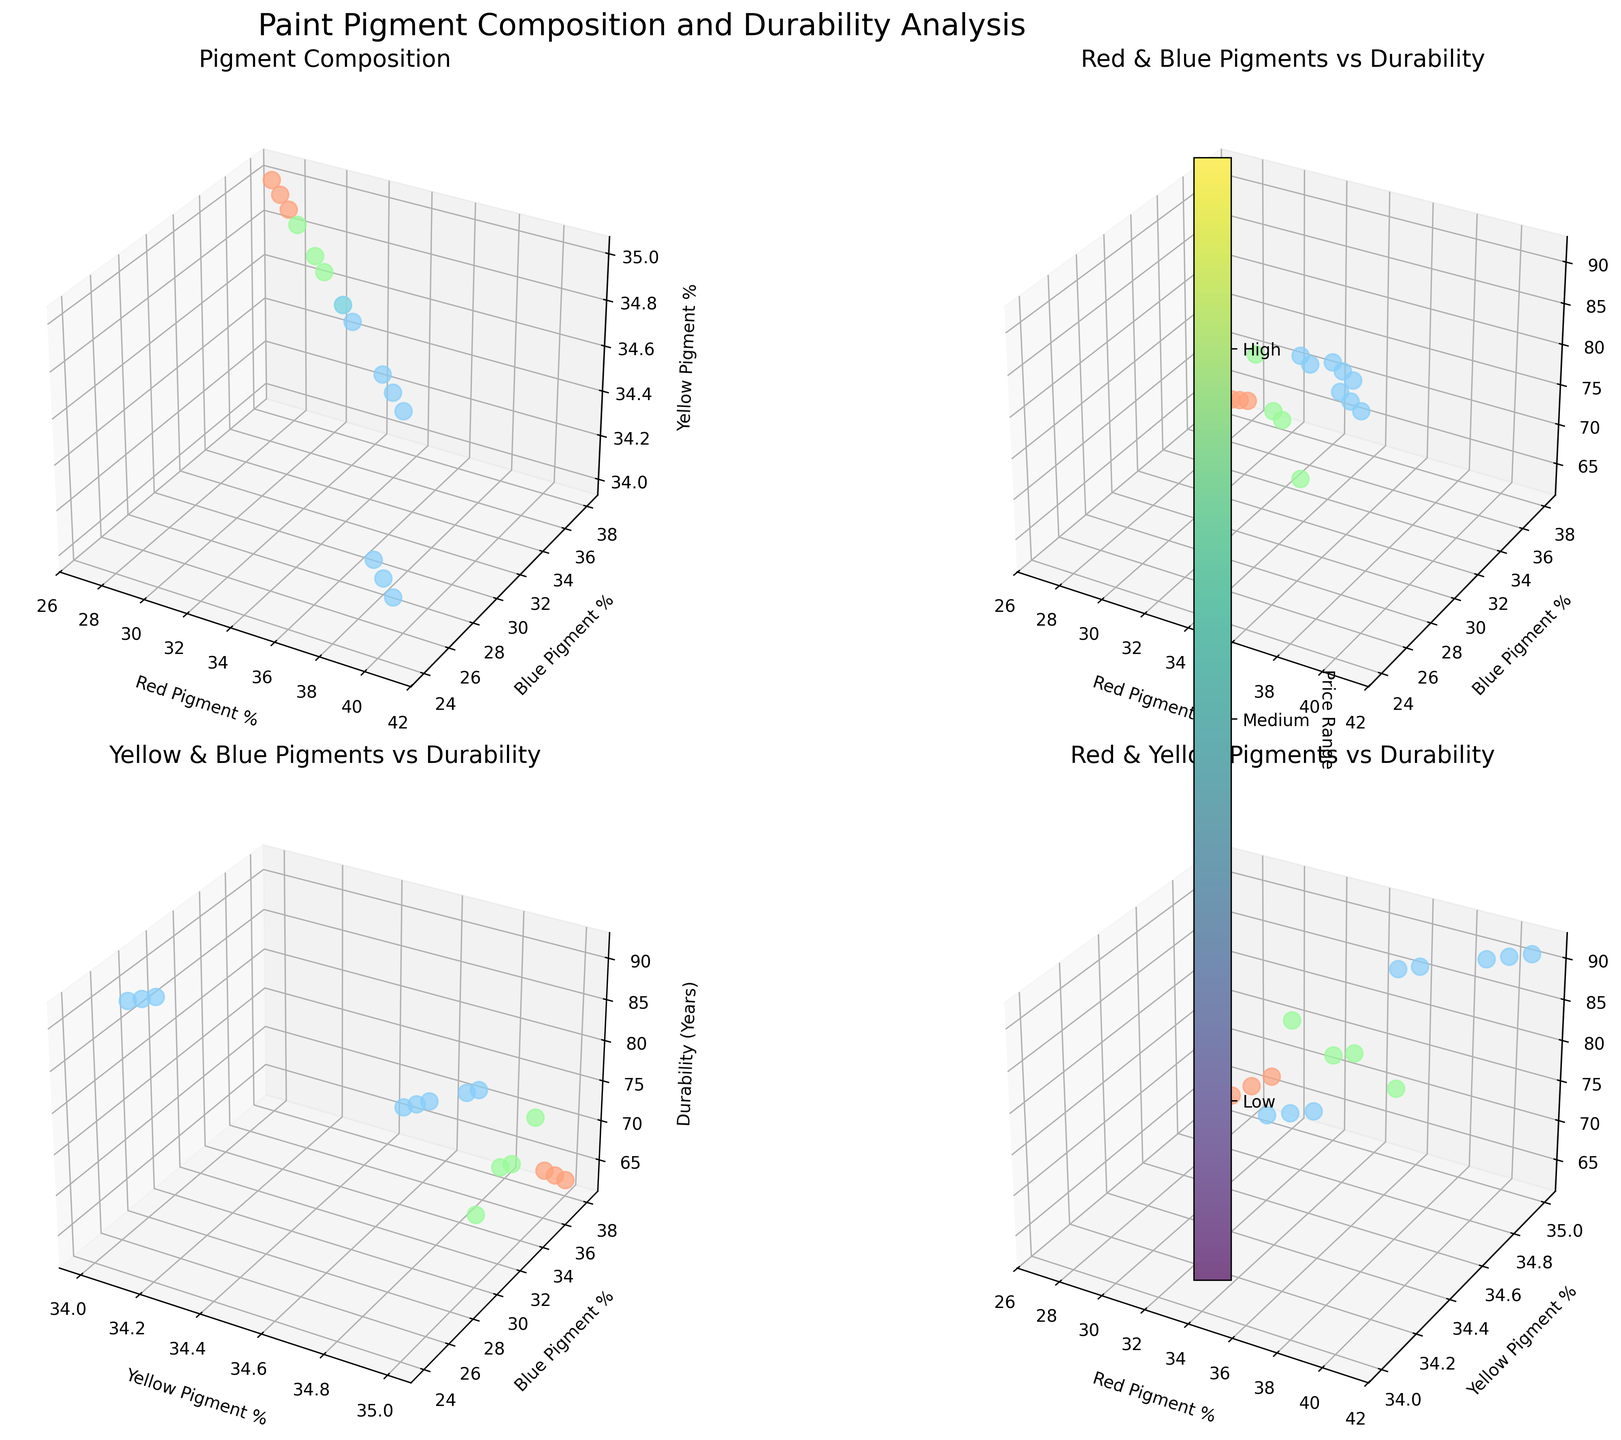What do the titles of the subplots indicate? The titles of the subplots specify what the axes represent in terms of pigment composition and durability. Plot 1 shows pigment composition with red, blue, and yellow pigment percentages. Plot 2 shows the relationship between red and blue pigments with durability. Plot 3 shows yellow and blue pigments with durability. Plot 4 shows red and yellow pigments with durability.
Answer: They indicate pigment composition and relationships between pigments and durability What color represents the 'High' price range? The 'High' price range is represented by light blue color in the plots, as indicated by the color bar.
Answer: Light blue Which brand has the highest durability? According to the subplots, Old Holland has the highest durability with 91 years, which is represented as a light blue dot near the top right in subplots 2 and 3.
Answer: Old Holland Does a higher percentage of red pigment always result in higher durability? No, while there is a general trend for higher red pigment percentages correlating with higher durability, there are exceptions like Liquitex with a medium price range, moderate red pigment, but lower durability compared to some high-price-range brands.
Answer: No How does the relationship between blue pigment percentage and durability differ for low and high price ranges? Low price range paints (represented by peach-color dots) cluster at lower durability and varying blue pigment percentages (~24-38%). High price range paints (represented by light blue dots) have consistently higher durability with blue pigment percentages around 24-30%.
Answer: Lower blue pigment, lower durability for low; moderate blue pigment, high durability for high Comparing Amsterdam and Daler-Rowney, which brand's durability is higher, and by how much? Amsterdam has a durability of 70 years, while Daler-Rowney has a durability of 72 years. Subtracting Amsterdam's durability from Daler-Rowney's gives 72 - 70 = 2.
Answer: Daler-Rowney by 2 years What trend can you observe between the yellow pigment percentage and durability? All brands have a yellow pigment percentage of 34-35%, implying that yellow pigment percentage is consistent across brands and not directly impacting durability by itself.
Answer: No clear trend Do more expensive brands generally offer higher durability? High price range brands, indicated by light blue, generally cluster toward higher durability in subplots 2, 3, and 4. Less expensive brands (peach-colored dots) cluster towards lower durability.
Answer: Yes Which combination of pigments shows the strongest correlation with durability? Red and blue pigments combined show a stronger correlation with durability; higher red percentages and moderate blue are associated with higher durability, as seen in subplot 2.
Answer: Red and blue 